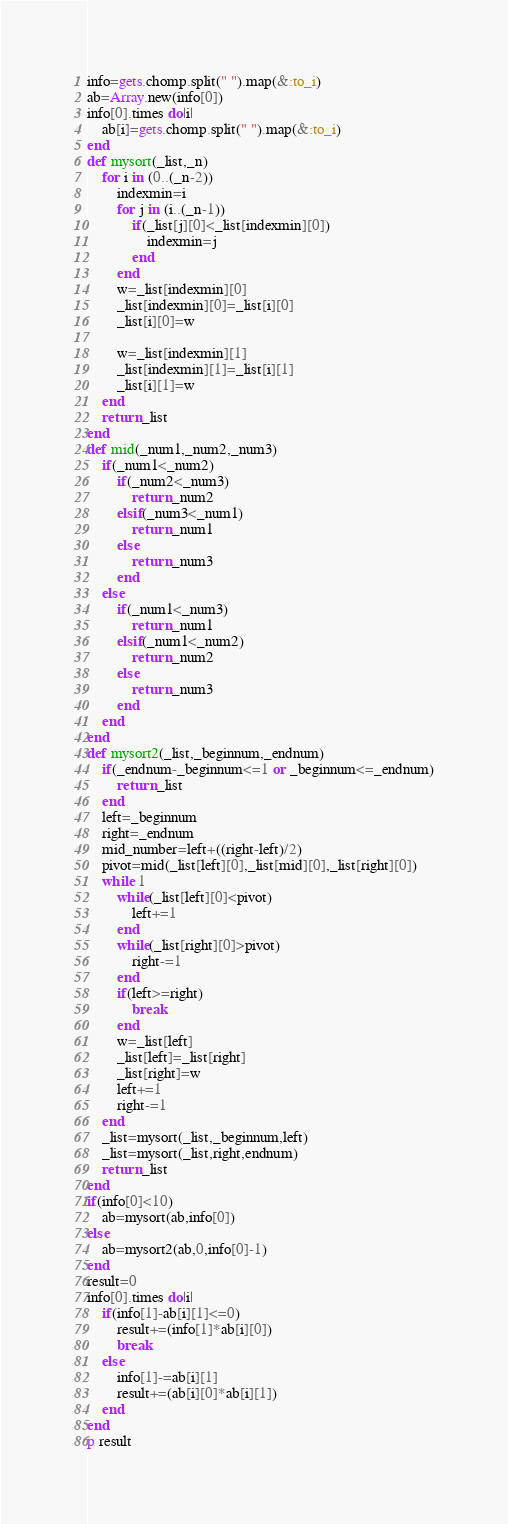<code> <loc_0><loc_0><loc_500><loc_500><_Ruby_>info=gets.chomp.split(" ").map(&:to_i)
ab=Array.new(info[0])
info[0].times do|i|
	ab[i]=gets.chomp.split(" ").map(&:to_i)
end
def mysort(_list,_n)
	for i in (0..(_n-2))
		indexmin=i
		for j in (i..(_n-1))
			if(_list[j][0]<_list[indexmin][0])
				indexmin=j
			end
		end
		w=_list[indexmin][0]
		_list[indexmin][0]=_list[i][0]
		_list[i][0]=w

		w=_list[indexmin][1]
		_list[indexmin][1]=_list[i][1]
		_list[i][1]=w
	end
	return _list
end
def mid(_num1,_num2,_num3)
	if(_num1<_num2)
		if(_num2<_num3)
			return _num2
		elsif(_num3<_num1)
			return _num1
		else
			return _num3
		end
	else
		if(_num1<_num3)
			return _num1
		elsif(_num1<_num2)
			return _num2
		else
			return _num3
		end
	end
end
def mysort2(_list,_beginnum,_endnum)
	if(_endnum-_beginnum<=1 or _beginnum<=_endnum)
		return _list
	end
	left=_beginnum
	right=_endnum
	mid_number=left+((right-left)/2)
	pivot=mid(_list[left][0],_list[mid][0],_list[right][0])
	while 1
		while(_list[left][0]<pivot)
			left+=1
		end
		while(_list[right][0]>pivot)
			right-=1
		end
		if(left>=right)
			break
		end
		w=_list[left]
		_list[left]=_list[right]
		_list[right]=w
		left+=1
		right-=1
	end
	_list=mysort(_list,_beginnum,left)
	_list=mysort(_list,right,endnum)
	return _list
end
if(info[0]<10)
	ab=mysort(ab,info[0])
else
	ab=mysort2(ab,0,info[0]-1)
end
result=0
info[0].times do|i|
	if(info[1]-ab[i][1]<=0)
		result+=(info[1]*ab[i][0])
		break
	else
		info[1]-=ab[i][1]
		result+=(ab[i][0]*ab[i][1])
	end
end
p result</code> 